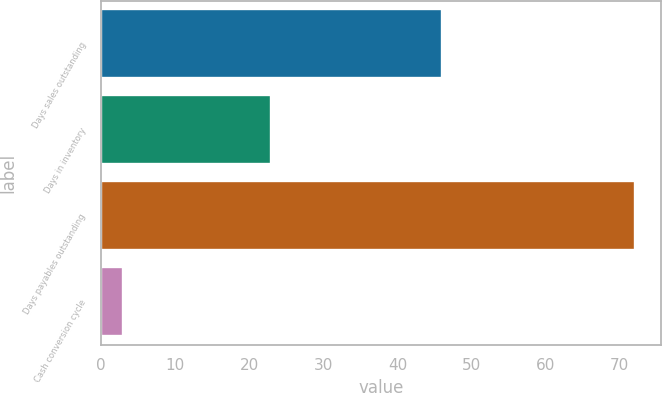Convert chart. <chart><loc_0><loc_0><loc_500><loc_500><bar_chart><fcel>Days sales outstanding<fcel>Days in inventory<fcel>Days payables outstanding<fcel>Cash conversion cycle<nl><fcel>46<fcel>23<fcel>72<fcel>3<nl></chart> 